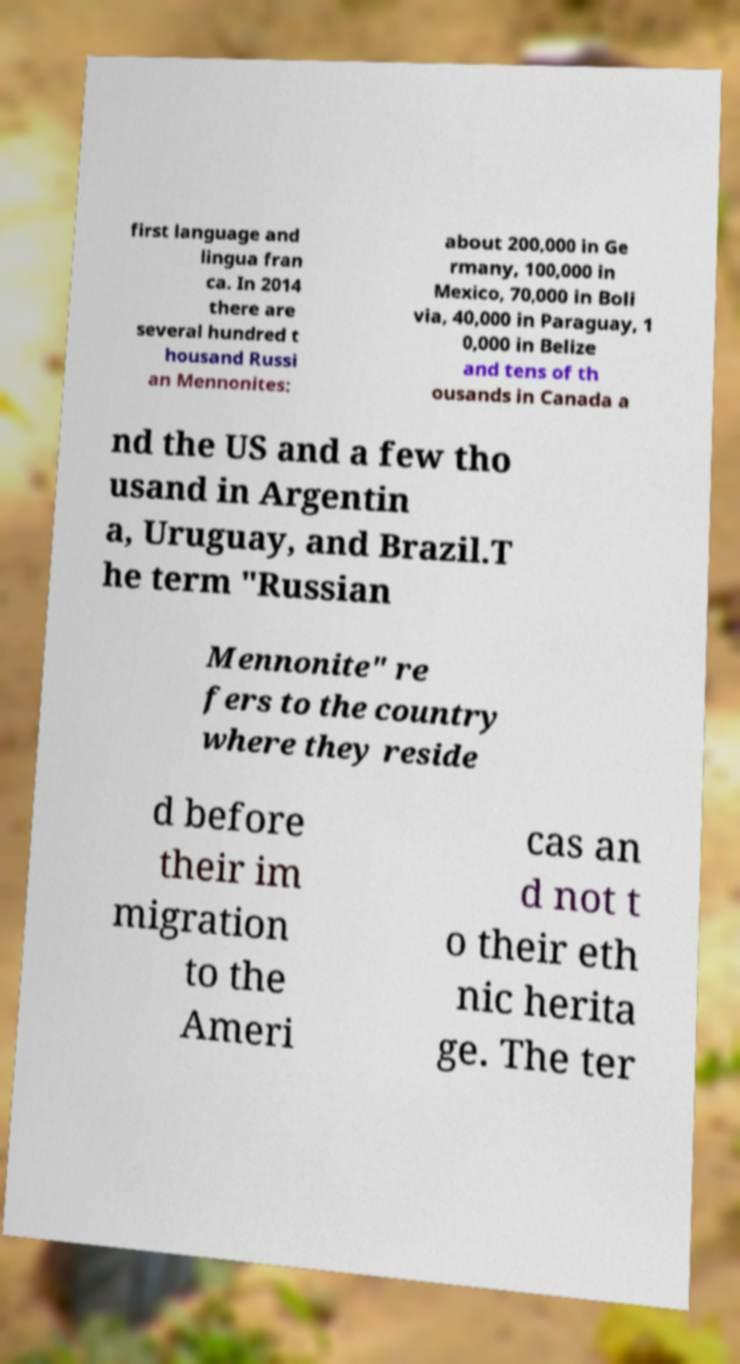Could you assist in decoding the text presented in this image and type it out clearly? first language and lingua fran ca. In 2014 there are several hundred t housand Russi an Mennonites: about 200,000 in Ge rmany, 100,000 in Mexico, 70,000 in Boli via, 40,000 in Paraguay, 1 0,000 in Belize and tens of th ousands in Canada a nd the US and a few tho usand in Argentin a, Uruguay, and Brazil.T he term "Russian Mennonite" re fers to the country where they reside d before their im migration to the Ameri cas an d not t o their eth nic herita ge. The ter 